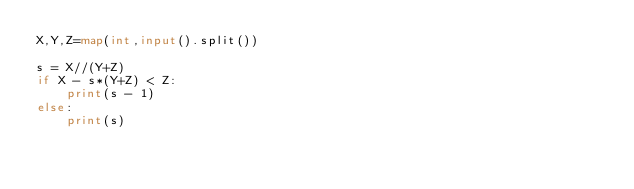Convert code to text. <code><loc_0><loc_0><loc_500><loc_500><_Python_>X,Y,Z=map(int,input().split())

s = X//(Y+Z)
if X - s*(Y+Z) < Z:
    print(s - 1)
else:
    print(s)
</code> 